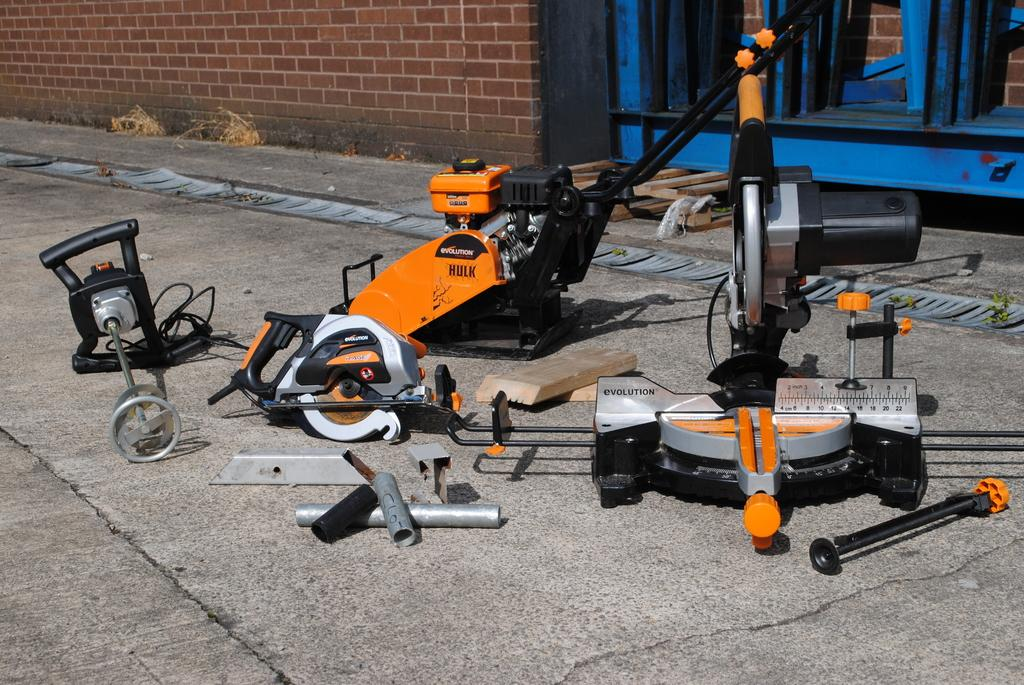What type of objects can be seen in the image? There is machinery in the image. Where is the machinery located? The machinery is placed on the land. What colors are the machinery? The machinery is in orange and black colors. What can be seen in the background of the image? There is a wall in the background of the image. What type of brain is visible in the image? There is no brain present in the image; it features machinery placed on the land. How many things can be counted in the image? The number of things in the image cannot be determined from the provided facts, as the focus is on the machinery and its characteristics. 